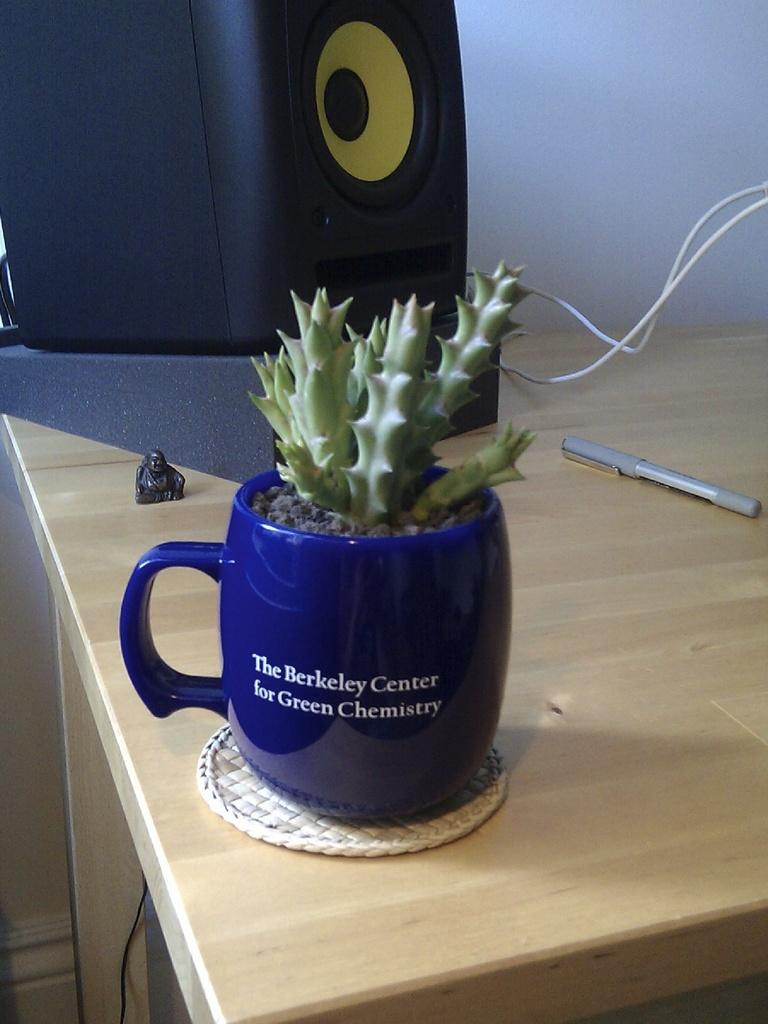What is the main piece of furniture in the image? There is a table in the image. What is placed on the table? There is a plant in a blue color mug on the table. What can be seen behind the table? There is a mini sculpture behind the table. What type of electronic device is present in the image? There is a black color speaker in the image. What are the two wires used for? The two wires are visible in the image, but their purpose is not specified. What stationary object is present in the image? There is a pen in the image. What type of lumber is used to construct the table in the image? The type of lumber used to construct the table is not specified in the image. Are there any stockings visible in the image? There are no stockings present in the image. 